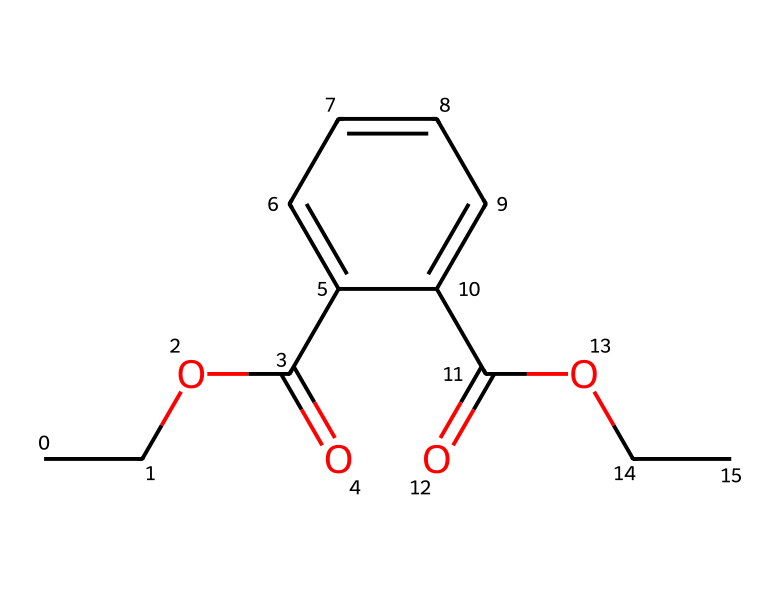What is the molecular formula of this chemical? To find the molecular formula, count the number of each type of atom present in the chemical structure represented by the SMILES. In this case, we can identify 14 carbon (C) atoms, 18 hydrogen (H) atoms, and 4 oxygen (O) atoms. Thus, the molecular formula is C14H18O4.
Answer: C14H18O4 How many rings are present in the structure? Analyze the SMILES representation for any indications of cyclic structures. The provided SMILES does not show any indication of a ring (like parentheses or numbers indicating bonds). Therefore, there are no rings in the structure.
Answer: 0 What type of functional groups are present in this molecule? Review the functional groups indicated by the SMILES, such as ester and carboxylic acid groups present in the structure. This structure contains both an ester group (C(=O)O) and a carboxylic acid group (C(=O)OH). Hence, the functional groups are ester and carboxylic acid.
Answer: ester, carboxylic acid Is this chemical classified as a carcinogen? Identify if phthalates, which include this chemical, are typically linked with carcinogenic effects. Many phthalates have been associated with adverse health effects, including potential carcinogenicity in certain contexts, but this classification can depend on specific testing and regulations. Therefore, it is generally considered hazardous.
Answer: yes What is the likely impact of this chemical on human health? Assess the known health effects of exposure to phthalates, which can include endocrine disruption and reproductive toxicity. Phthalates are often linked to a variety of harmful effects, particularly in children, as they can interfere with hormone function. Thus, the likely impact is hazardous health effects.
Answer: hazardous health effects 